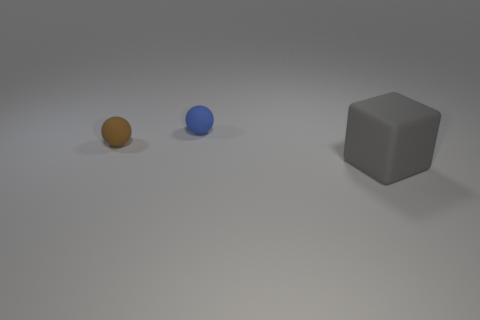What number of other objects are there of the same shape as the tiny blue thing?
Your response must be concise. 1. There is a blue object right of the small brown sphere; what shape is it?
Offer a terse response. Sphere. The large object is what color?
Make the answer very short. Gray. How many other things are there of the same size as the gray rubber object?
Give a very brief answer. 0. What material is the thing in front of the small sphere that is in front of the small blue matte object made of?
Keep it short and to the point. Rubber. There is a brown rubber ball; is its size the same as the thing that is to the right of the blue ball?
Ensure brevity in your answer.  No. Is there a sphere that has the same color as the large matte block?
Offer a very short reply. No. How many small things are either metallic cylinders or brown matte balls?
Offer a terse response. 1. What number of blue rubber balls are there?
Give a very brief answer. 1. There is a ball that is in front of the blue sphere; what is it made of?
Give a very brief answer. Rubber. 